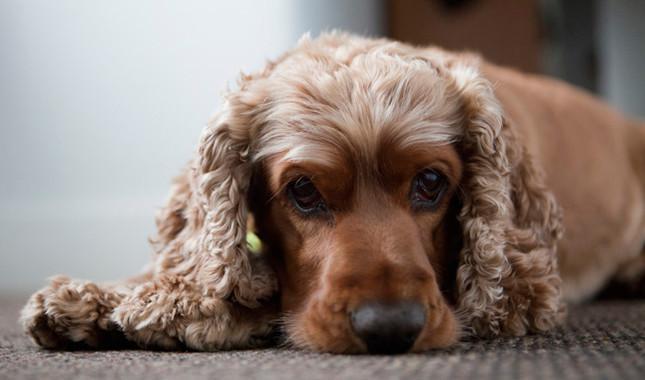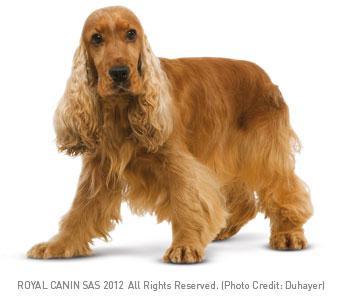The first image is the image on the left, the second image is the image on the right. Analyze the images presented: Is the assertion "There is at least one dog against a plain white background in the image on the left." valid? Answer yes or no. No. The first image is the image on the left, the second image is the image on the right. Analyze the images presented: Is the assertion "A dog is standing on all fours in one of the images" valid? Answer yes or no. Yes. 